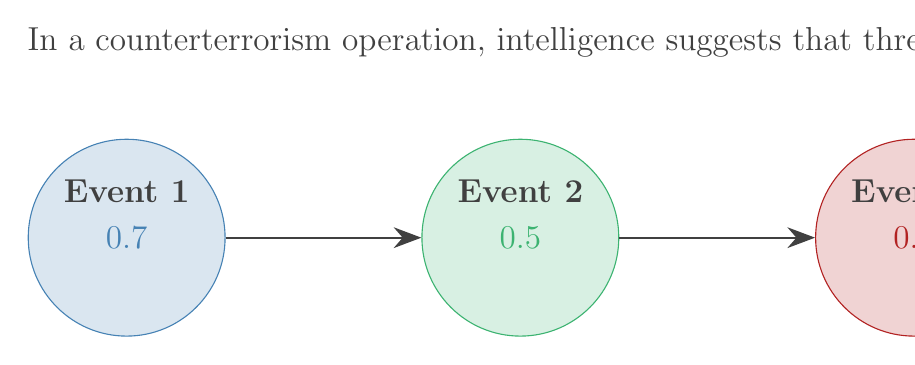Solve this math problem. To solve this problem, we need to use the multiplication rule of probability for independent events occurring in a specific sequence. The steps are as follows:

1) The probability of each event occurring independently is given:
   Event 1: $P(E_1) = 0.7$
   Event 2: $P(E_2) = 0.5$
   Event 3: $P(E_3) = 0.3$

2) For all three events to occur in the exact sequence, we need to multiply these probabilities:

   $$P(E_1 \text{ and } E_2 \text{ and } E_3) = P(E_1) \times P(E_2) \times P(E_3)$$

3) Substituting the values:

   $$P(E_1 \text{ and } E_2 \text{ and } E_3) = 0.7 \times 0.5 \times 0.3$$

4) Calculating:

   $$P(E_1 \text{ and } E_2 \text{ and } E_3) = 0.105$$

5) Converting to a percentage:

   $$0.105 \times 100\% = 10.5\%$$

Therefore, the probability that all three events will occur in the exact sequence required is 0.105 or 10.5%.
Answer: 0.105 or 10.5% 